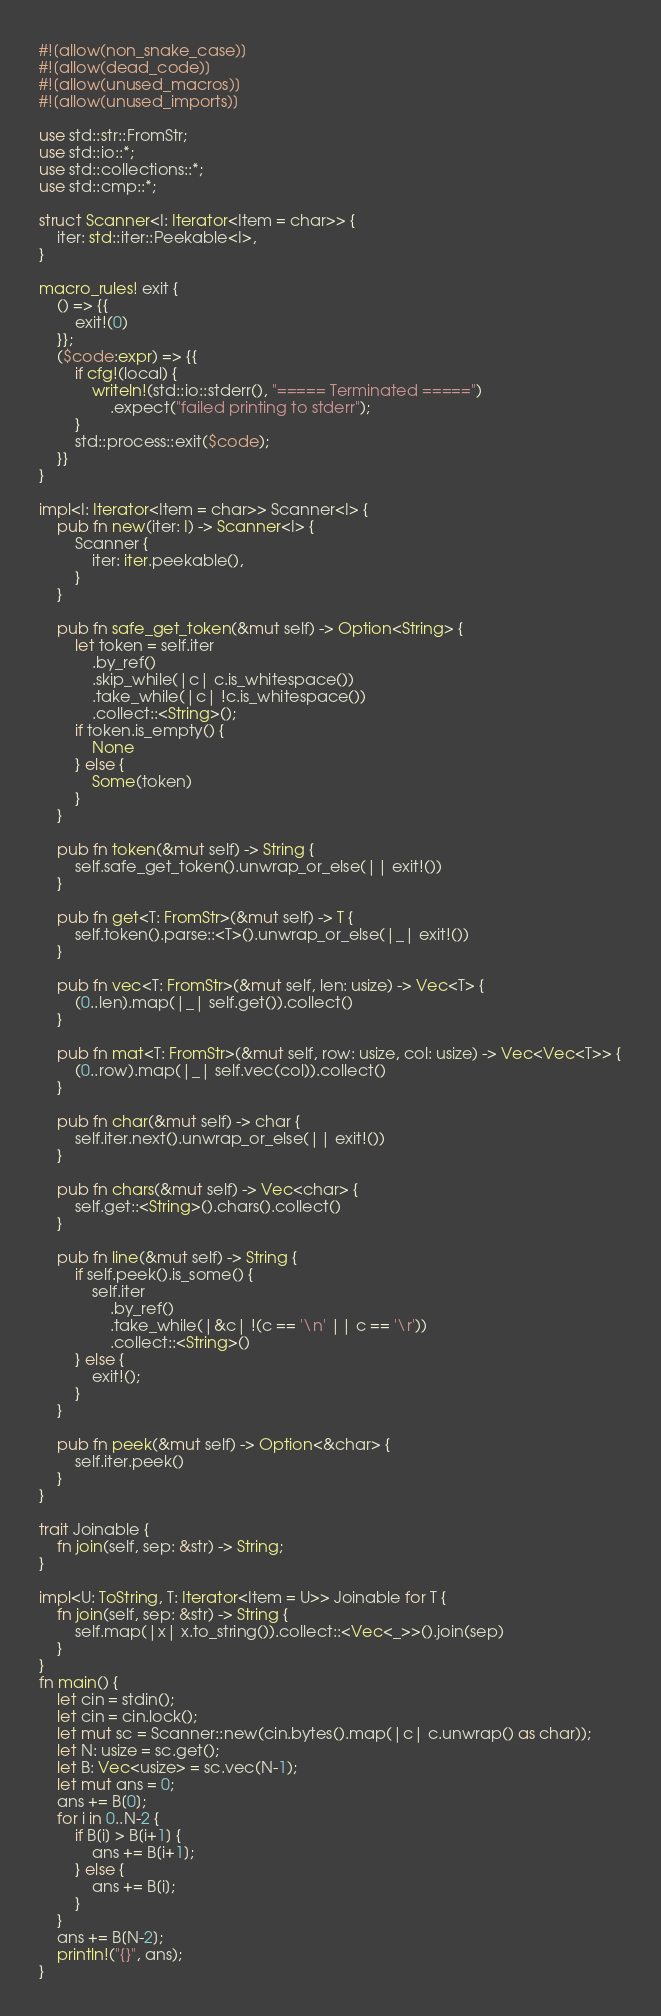Convert code to text. <code><loc_0><loc_0><loc_500><loc_500><_Rust_>#![allow(non_snake_case)]
#![allow(dead_code)]
#![allow(unused_macros)]
#![allow(unused_imports)]

use std::str::FromStr;
use std::io::*;
use std::collections::*;
use std::cmp::*;

struct Scanner<I: Iterator<Item = char>> {
    iter: std::iter::Peekable<I>,
}

macro_rules! exit {
    () => {{
        exit!(0)
    }};
    ($code:expr) => {{
        if cfg!(local) {
            writeln!(std::io::stderr(), "===== Terminated =====")
                .expect("failed printing to stderr");
        }
        std::process::exit($code);
    }}
}

impl<I: Iterator<Item = char>> Scanner<I> {
    pub fn new(iter: I) -> Scanner<I> {
        Scanner {
            iter: iter.peekable(),
        }
    }

    pub fn safe_get_token(&mut self) -> Option<String> {
        let token = self.iter
            .by_ref()
            .skip_while(|c| c.is_whitespace())
            .take_while(|c| !c.is_whitespace())
            .collect::<String>();
        if token.is_empty() {
            None
        } else {
            Some(token)
        }
    }

    pub fn token(&mut self) -> String {
        self.safe_get_token().unwrap_or_else(|| exit!())
    }

    pub fn get<T: FromStr>(&mut self) -> T {
        self.token().parse::<T>().unwrap_or_else(|_| exit!())
    }

    pub fn vec<T: FromStr>(&mut self, len: usize) -> Vec<T> {
        (0..len).map(|_| self.get()).collect()
    }

    pub fn mat<T: FromStr>(&mut self, row: usize, col: usize) -> Vec<Vec<T>> {
        (0..row).map(|_| self.vec(col)).collect()
    }

    pub fn char(&mut self) -> char {
        self.iter.next().unwrap_or_else(|| exit!())
    }

    pub fn chars(&mut self) -> Vec<char> {
        self.get::<String>().chars().collect()
    }

    pub fn line(&mut self) -> String {
        if self.peek().is_some() {
            self.iter
                .by_ref()
                .take_while(|&c| !(c == '\n' || c == '\r'))
                .collect::<String>()
        } else {
            exit!();
        }
    }

    pub fn peek(&mut self) -> Option<&char> {
        self.iter.peek()
    }
}

trait Joinable {
    fn join(self, sep: &str) -> String;
}

impl<U: ToString, T: Iterator<Item = U>> Joinable for T {
    fn join(self, sep: &str) -> String {
        self.map(|x| x.to_string()).collect::<Vec<_>>().join(sep)
    }
}
fn main() {
    let cin = stdin();
    let cin = cin.lock();
    let mut sc = Scanner::new(cin.bytes().map(|c| c.unwrap() as char));
    let N: usize = sc.get();
    let B: Vec<usize> = sc.vec(N-1);
    let mut ans = 0;
    ans += B[0];
    for i in 0..N-2 {
        if B[i] > B[i+1] {
            ans += B[i+1];
        } else {
            ans += B[i];
        }
    }
    ans += B[N-2];
    println!("{}", ans);
}
</code> 